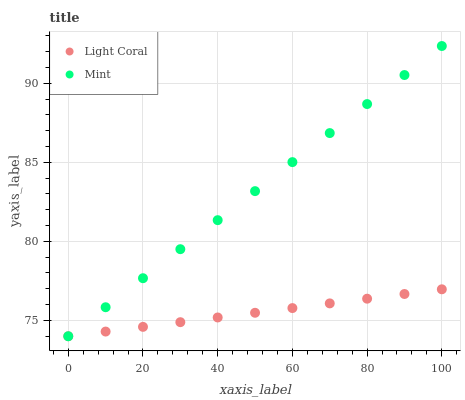Does Light Coral have the minimum area under the curve?
Answer yes or no. Yes. Does Mint have the maximum area under the curve?
Answer yes or no. Yes. Does Mint have the minimum area under the curve?
Answer yes or no. No. Is Mint the smoothest?
Answer yes or no. Yes. Is Light Coral the roughest?
Answer yes or no. Yes. Is Mint the roughest?
Answer yes or no. No. Does Light Coral have the lowest value?
Answer yes or no. Yes. Does Mint have the highest value?
Answer yes or no. Yes. Does Mint intersect Light Coral?
Answer yes or no. Yes. Is Mint less than Light Coral?
Answer yes or no. No. Is Mint greater than Light Coral?
Answer yes or no. No. 